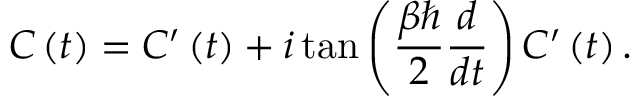<formula> <loc_0><loc_0><loc_500><loc_500>C \left ( t \right ) = C ^ { \prime } \left ( t \right ) + i \tan \left ( \frac { \beta } { 2 } \frac { d } { d t } \right ) C ^ { \prime } \left ( t \right ) .</formula> 